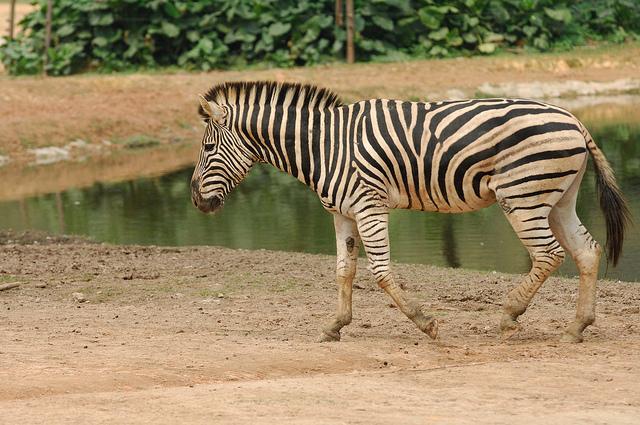What kind of ground is the zebra walking on?
Concise answer only. Dirt. What is the scenery?
Answer briefly. Zoo. Is the zebra standing still?
Concise answer only. No. Are the zebra's stripes all straight?
Concise answer only. No. 